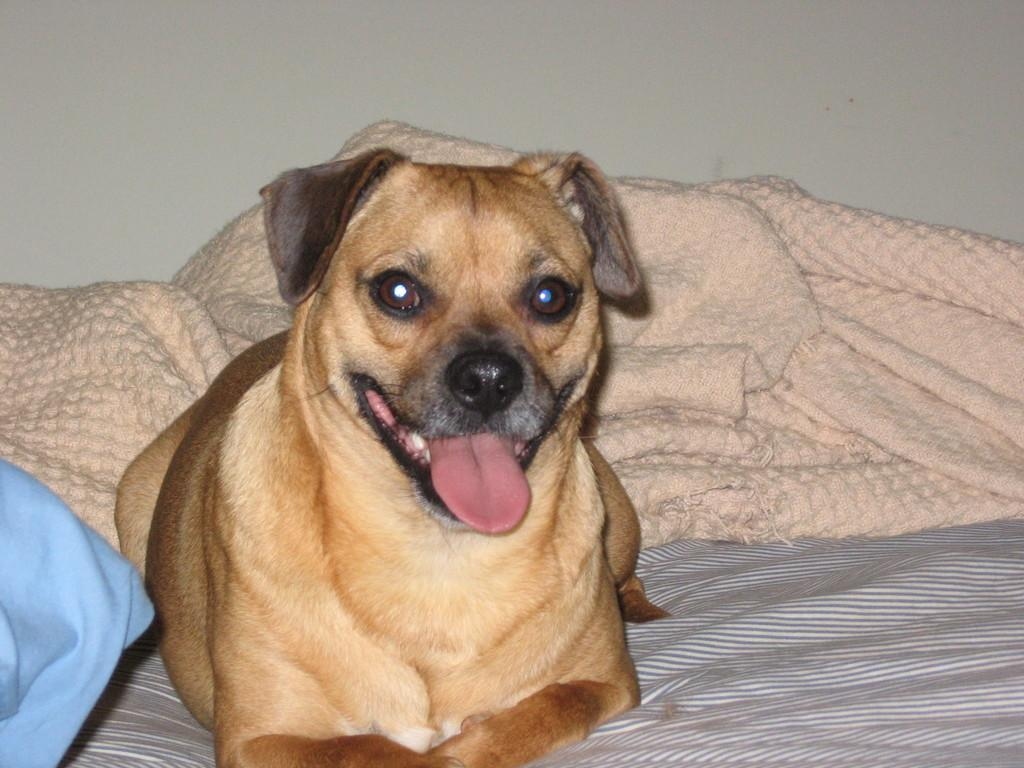What type of animal is in the image? There is a brown dog in the image. What is the dog doing in the image? The dog is resting on a bed. What can be seen in the background of the image? There is a cream-colored blanket and a wall visible in the background of the image. What type of yard game is the dog playing in the image? There is no yard game present in the image; the dog is resting on a bed. What type of writing instrument is the dog holding in the image? There is no writing instrument present in the image; the dog is simply resting on a bed. 